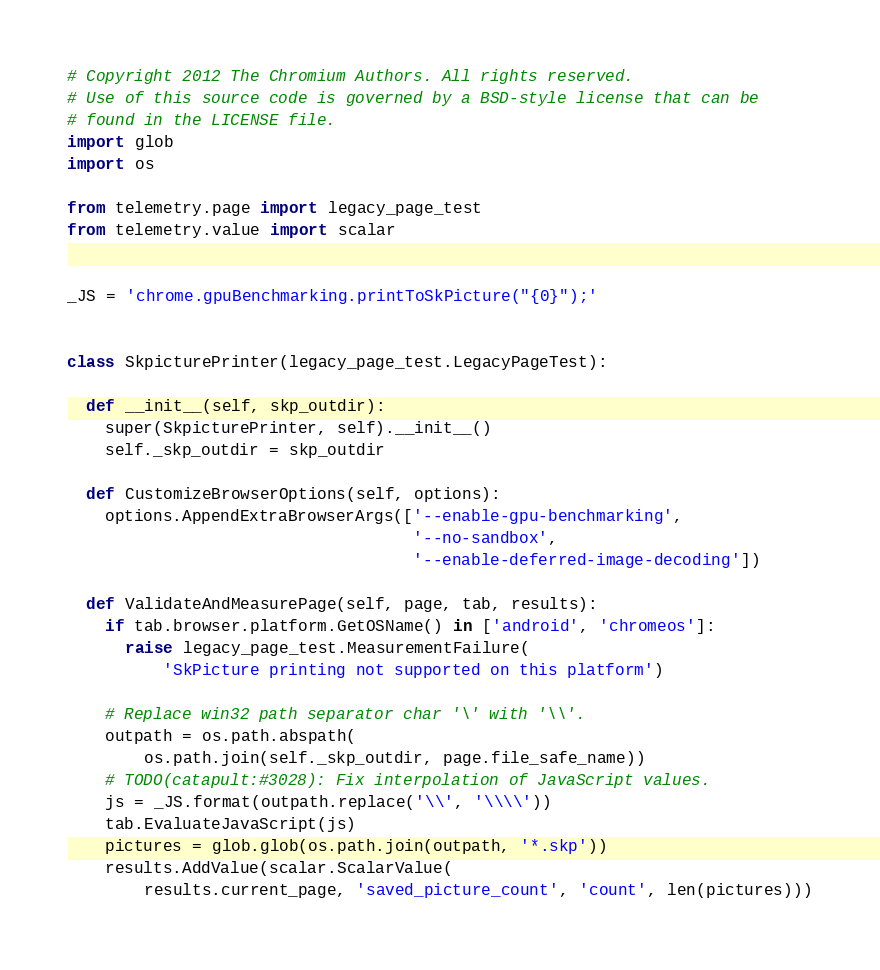Convert code to text. <code><loc_0><loc_0><loc_500><loc_500><_Python_># Copyright 2012 The Chromium Authors. All rights reserved.
# Use of this source code is governed by a BSD-style license that can be
# found in the LICENSE file.
import glob
import os

from telemetry.page import legacy_page_test
from telemetry.value import scalar


_JS = 'chrome.gpuBenchmarking.printToSkPicture("{0}");'


class SkpicturePrinter(legacy_page_test.LegacyPageTest):

  def __init__(self, skp_outdir):
    super(SkpicturePrinter, self).__init__()
    self._skp_outdir = skp_outdir

  def CustomizeBrowserOptions(self, options):
    options.AppendExtraBrowserArgs(['--enable-gpu-benchmarking',
                                    '--no-sandbox',
                                    '--enable-deferred-image-decoding'])

  def ValidateAndMeasurePage(self, page, tab, results):
    if tab.browser.platform.GetOSName() in ['android', 'chromeos']:
      raise legacy_page_test.MeasurementFailure(
          'SkPicture printing not supported on this platform')

    # Replace win32 path separator char '\' with '\\'.
    outpath = os.path.abspath(
        os.path.join(self._skp_outdir, page.file_safe_name))
    # TODO(catapult:#3028): Fix interpolation of JavaScript values.
    js = _JS.format(outpath.replace('\\', '\\\\'))
    tab.EvaluateJavaScript(js)
    pictures = glob.glob(os.path.join(outpath, '*.skp'))
    results.AddValue(scalar.ScalarValue(
        results.current_page, 'saved_picture_count', 'count', len(pictures)))
</code> 